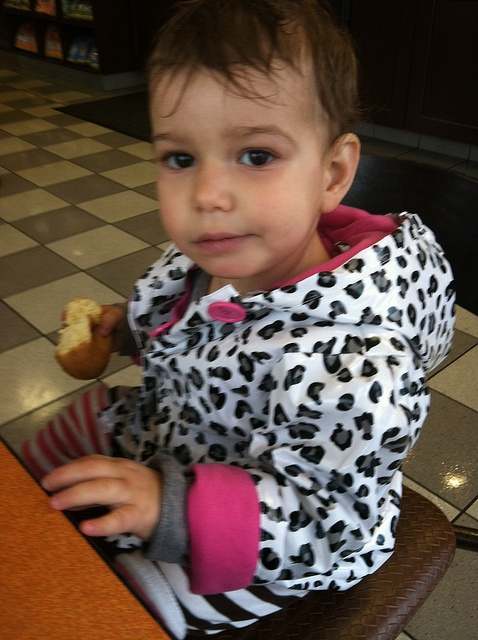Describe the objects in this image and their specific colors. I can see people in black, brown, lightgray, and gray tones, dining table in black, brown, and maroon tones, chair in black, maroon, and gray tones, and donut in black, maroon, and tan tones in this image. 